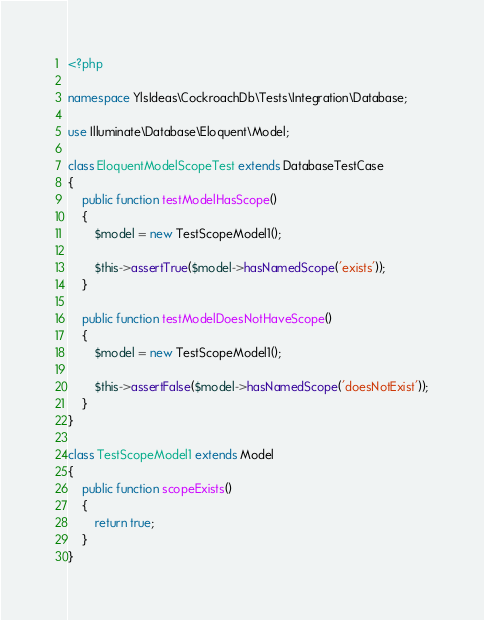Convert code to text. <code><loc_0><loc_0><loc_500><loc_500><_PHP_><?php

namespace YlsIdeas\CockroachDb\Tests\Integration\Database;

use Illuminate\Database\Eloquent\Model;

class EloquentModelScopeTest extends DatabaseTestCase
{
    public function testModelHasScope()
    {
        $model = new TestScopeModel1();

        $this->assertTrue($model->hasNamedScope('exists'));
    }

    public function testModelDoesNotHaveScope()
    {
        $model = new TestScopeModel1();

        $this->assertFalse($model->hasNamedScope('doesNotExist'));
    }
}

class TestScopeModel1 extends Model
{
    public function scopeExists()
    {
        return true;
    }
}
</code> 